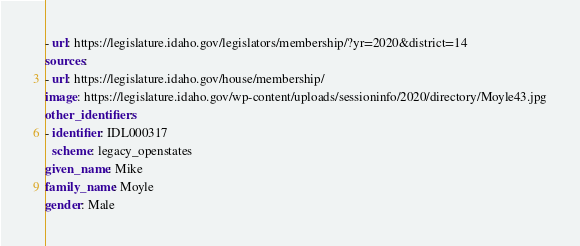<code> <loc_0><loc_0><loc_500><loc_500><_YAML_>- url: https://legislature.idaho.gov/legislators/membership/?yr=2020&district=14
sources:
- url: https://legislature.idaho.gov/house/membership/
image: https://legislature.idaho.gov/wp-content/uploads/sessioninfo/2020/directory/Moyle43.jpg
other_identifiers:
- identifier: IDL000317
  scheme: legacy_openstates
given_name: Mike
family_name: Moyle
gender: Male
</code> 